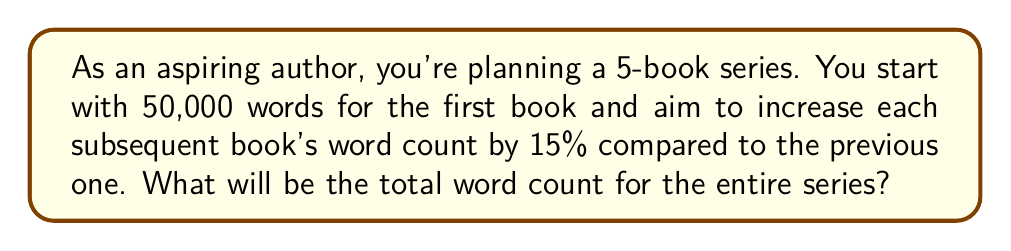Solve this math problem. Let's approach this step-by-step:

1) First, let's calculate the word count for each book:

   Book 1: 50,000 words
   Book 2: $50,000 \times 1.15 = 57,500$ words
   Book 3: $57,500 \times 1.15 = 66,125$ words
   Book 4: $66,125 \times 1.15 = 76,043.75$ words
   Book 5: $76,043.75 \times 1.15 = 87,450.31$ words

2) Now, we can represent this as a geometric sequence with:
   $a = 50,000$ (first term)
   $r = 1.15$ (common ratio)
   $n = 5$ (number of terms)

3) The sum of a geometric sequence is given by the formula:

   $$S_n = \frac{a(1-r^n)}{1-r}$$

   Where $S_n$ is the sum of the sequence, $a$ is the first term, $r$ is the common ratio, and $n$ is the number of terms.

4) Plugging in our values:

   $$S_5 = \frac{50,000(1-1.15^5)}{1-1.15}$$

5) Calculating:

   $$S_5 = \frac{50,000(1-2.0113)}{-0.15} = \frac{50,000(-1.0113)}{-0.15} = 337,100$$

6) Rounding to the nearest whole number (as we can't have partial words), we get 337,100 words.
Answer: 337,100 words 